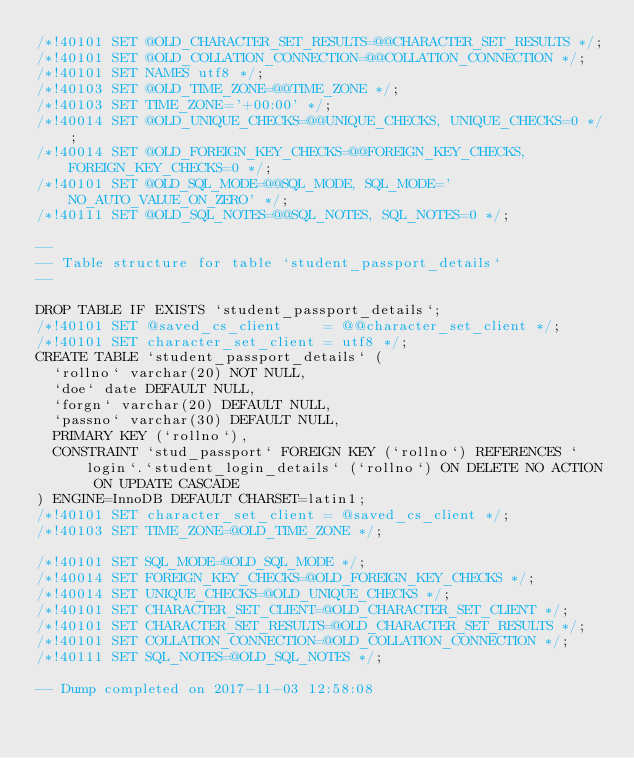<code> <loc_0><loc_0><loc_500><loc_500><_SQL_>/*!40101 SET @OLD_CHARACTER_SET_RESULTS=@@CHARACTER_SET_RESULTS */;
/*!40101 SET @OLD_COLLATION_CONNECTION=@@COLLATION_CONNECTION */;
/*!40101 SET NAMES utf8 */;
/*!40103 SET @OLD_TIME_ZONE=@@TIME_ZONE */;
/*!40103 SET TIME_ZONE='+00:00' */;
/*!40014 SET @OLD_UNIQUE_CHECKS=@@UNIQUE_CHECKS, UNIQUE_CHECKS=0 */;
/*!40014 SET @OLD_FOREIGN_KEY_CHECKS=@@FOREIGN_KEY_CHECKS, FOREIGN_KEY_CHECKS=0 */;
/*!40101 SET @OLD_SQL_MODE=@@SQL_MODE, SQL_MODE='NO_AUTO_VALUE_ON_ZERO' */;
/*!40111 SET @OLD_SQL_NOTES=@@SQL_NOTES, SQL_NOTES=0 */;

--
-- Table structure for table `student_passport_details`
--

DROP TABLE IF EXISTS `student_passport_details`;
/*!40101 SET @saved_cs_client     = @@character_set_client */;
/*!40101 SET character_set_client = utf8 */;
CREATE TABLE `student_passport_details` (
  `rollno` varchar(20) NOT NULL,
  `doe` date DEFAULT NULL,
  `forgn` varchar(20) DEFAULT NULL,
  `passno` varchar(30) DEFAULT NULL,
  PRIMARY KEY (`rollno`),
  CONSTRAINT `stud_passport` FOREIGN KEY (`rollno`) REFERENCES `login`.`student_login_details` (`rollno`) ON DELETE NO ACTION ON UPDATE CASCADE
) ENGINE=InnoDB DEFAULT CHARSET=latin1;
/*!40101 SET character_set_client = @saved_cs_client */;
/*!40103 SET TIME_ZONE=@OLD_TIME_ZONE */;

/*!40101 SET SQL_MODE=@OLD_SQL_MODE */;
/*!40014 SET FOREIGN_KEY_CHECKS=@OLD_FOREIGN_KEY_CHECKS */;
/*!40014 SET UNIQUE_CHECKS=@OLD_UNIQUE_CHECKS */;
/*!40101 SET CHARACTER_SET_CLIENT=@OLD_CHARACTER_SET_CLIENT */;
/*!40101 SET CHARACTER_SET_RESULTS=@OLD_CHARACTER_SET_RESULTS */;
/*!40101 SET COLLATION_CONNECTION=@OLD_COLLATION_CONNECTION */;
/*!40111 SET SQL_NOTES=@OLD_SQL_NOTES */;

-- Dump completed on 2017-11-03 12:58:08
</code> 